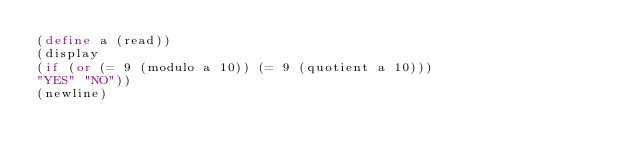<code> <loc_0><loc_0><loc_500><loc_500><_Scheme_>(define a (read))
(display
(if (or (= 9 (modulo a 10)) (= 9 (quotient a 10)))
"YES" "NO"))
(newline)</code> 